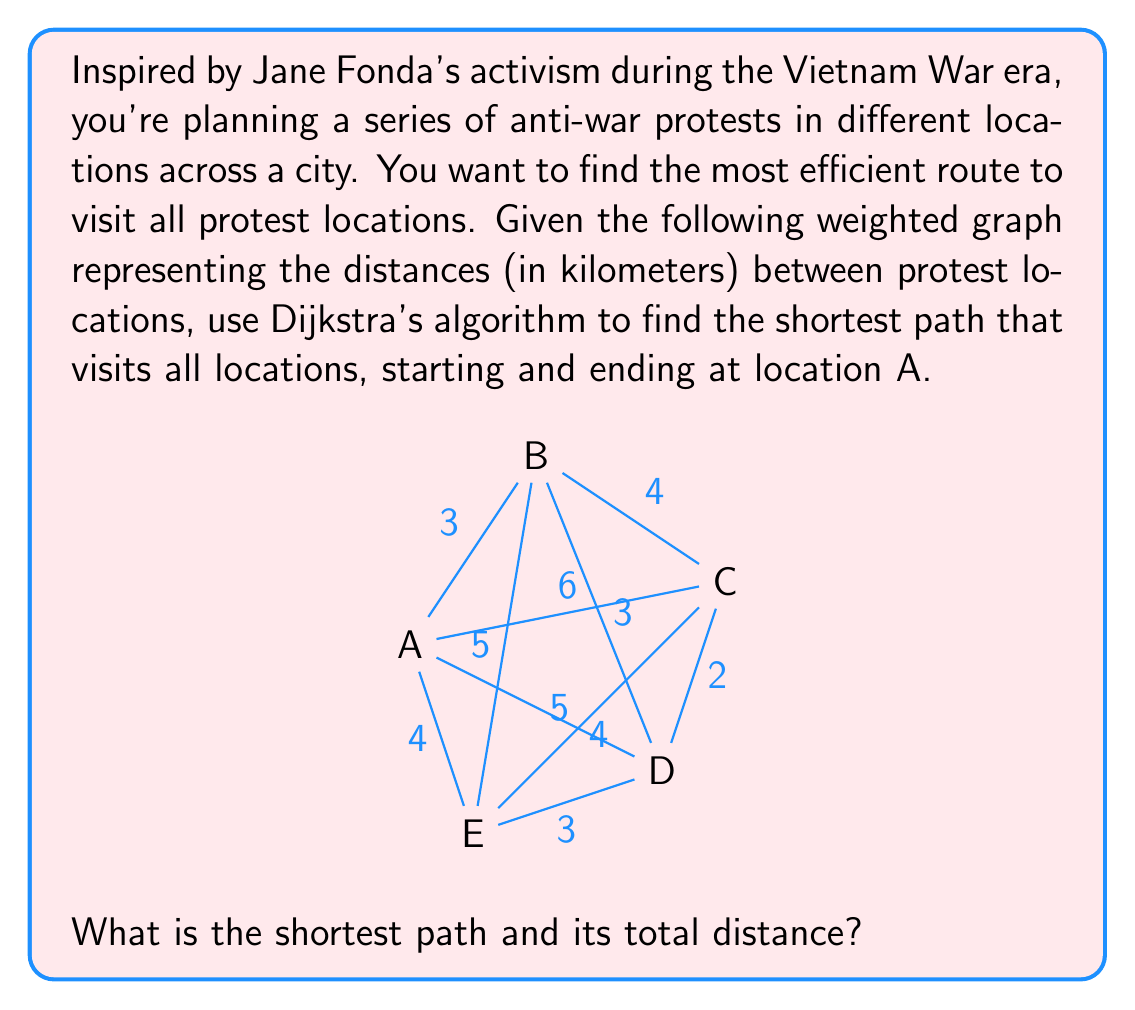Could you help me with this problem? To solve this problem, we'll use Dijkstra's algorithm to find the shortest path from A to all other vertices, and then construct the optimal route.

Step 1: Initialize distances
$d(A) = 0$, $d(B) = \infty$, $d(C) = \infty$, $d(D) = \infty$, $d(E) = \infty$

Step 2: Apply Dijkstra's algorithm
1. From A:
   $d(B) = 3$, $d(C) = 6$, $d(D) = 5$, $d(E) = 4$
2. From B:
   $d(C) = \min(6, 3+4) = 6$, $d(D) = \min(5, 3+3) = 5$, $d(E) = \min(4, 3+5) = 4$
3. From E:
   $d(C) = \min(6, 4+4) = 6$, $d(D) = \min(5, 4+3) = 5$
4. From D:
   $d(C) = \min(6, 5+2) = 6$

Step 3: Construct the shortest path
Starting from A, we'll visit each location in order of increasing distance:
A → B (3 km) → E (4 km) → D (5 km) → C (6 km) → A (6 km)

The total distance of this path is:
$$3 + (4-3) + (5-4) + (6-5) + 6 = 12\text{ km}$$
Answer: The shortest path is A → B → E → D → C → A, with a total distance of 12 km. 